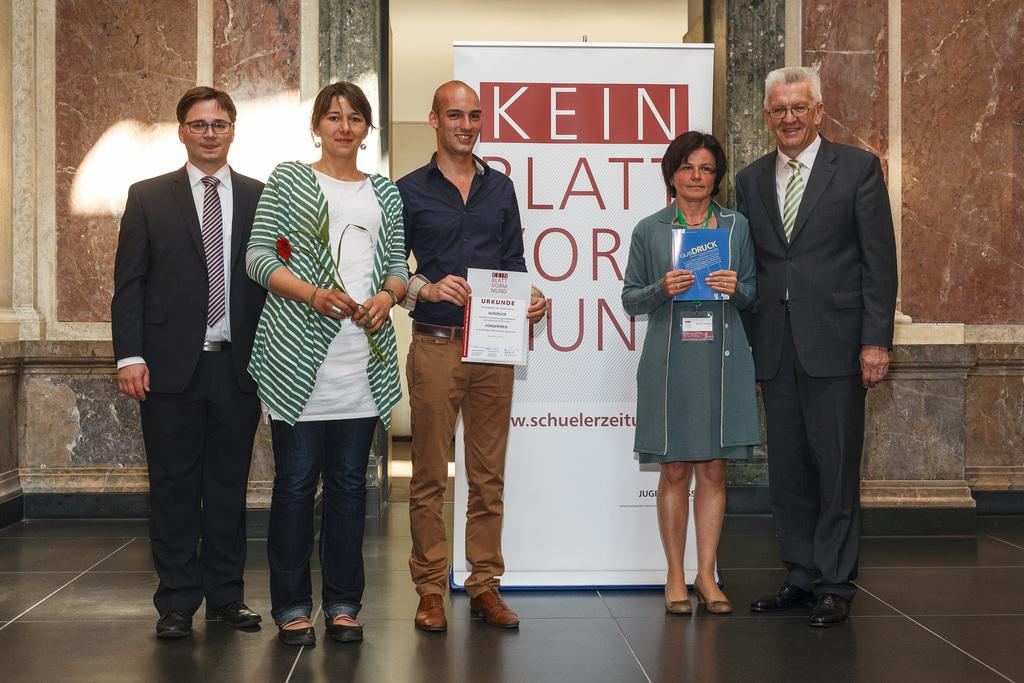How many people are present in the image? There are five persons standing in the image. What is the facial expression of the people in the image? The persons are smiling. What are two of the persons holding in the image? Two of the persons are holding a book. What can be seen in the background of the image? There is a banner and a wall in the background of the image. How many legs can be seen on the wire in the image? There is no wire or legs present in the image. What type of servant is attending to the persons in the image? There is no servant present in the image; it features five persons standing and smiling. 